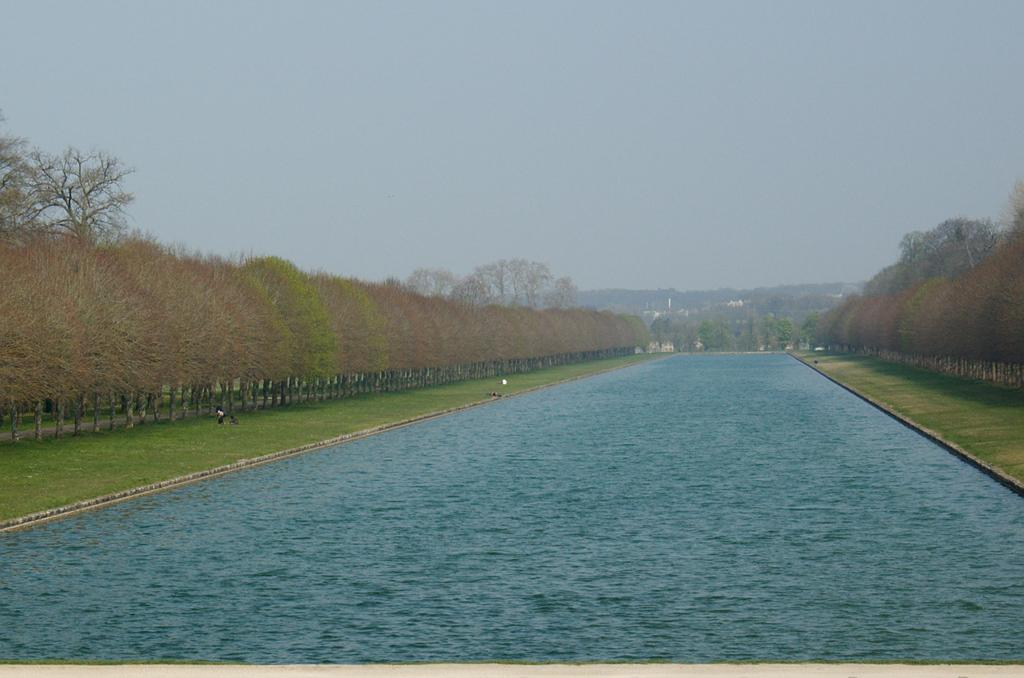What is located in the middle of the image? There is water in the middle of the image. What type of vegetation can be seen in the image? There are green trees in the image. What is visible at the top of the image? The sky is visible at the top of the image. Can you tell me how many geese are attacking the horses in the image? There are no geese or horses present in the image; it features water and green trees. 